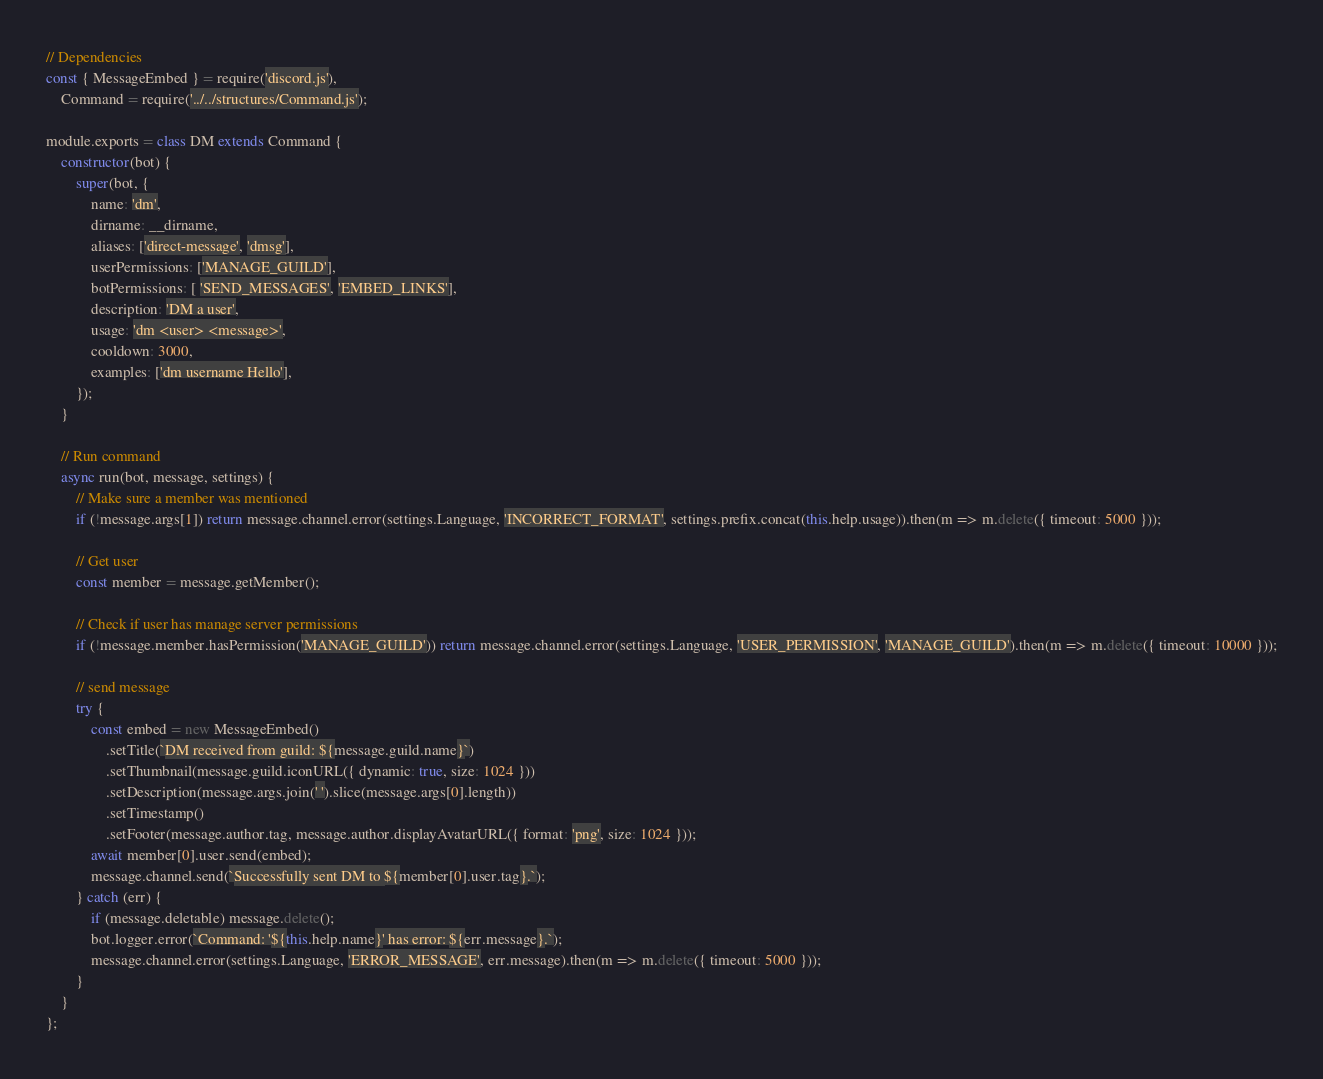Convert code to text. <code><loc_0><loc_0><loc_500><loc_500><_JavaScript_>// Dependencies
const { MessageEmbed } = require('discord.js'),
	Command = require('../../structures/Command.js');

module.exports = class DM extends Command {
	constructor(bot) {
		super(bot, {
			name: 'dm',
			dirname: __dirname,
			aliases: ['direct-message', 'dmsg'],
			userPermissions: ['MANAGE_GUILD'],
			botPermissions: [ 'SEND_MESSAGES', 'EMBED_LINKS'],
			description: 'DM a user',
			usage: 'dm <user> <message>',
			cooldown: 3000,
			examples: ['dm username Hello'],
		});
	}

	// Run command
	async run(bot, message, settings) {
		// Make sure a member was mentioned
		if (!message.args[1]) return message.channel.error(settings.Language, 'INCORRECT_FORMAT', settings.prefix.concat(this.help.usage)).then(m => m.delete({ timeout: 5000 }));

		// Get user
		const member = message.getMember();

		// Check if user has manage server permissions
		if (!message.member.hasPermission('MANAGE_GUILD')) return message.channel.error(settings.Language, 'USER_PERMISSION', 'MANAGE_GUILD').then(m => m.delete({ timeout: 10000 }));

		// send message
		try {
			const embed = new MessageEmbed()
				.setTitle(`DM received from guild: ${message.guild.name}`)
				.setThumbnail(message.guild.iconURL({ dynamic: true, size: 1024 }))
				.setDescription(message.args.join(' ').slice(message.args[0].length))
				.setTimestamp()
				.setFooter(message.author.tag, message.author.displayAvatarURL({ format: 'png', size: 1024 }));
			await member[0].user.send(embed);
			message.channel.send(`Successfully sent DM to ${member[0].user.tag}.`);
		} catch (err) {
			if (message.deletable) message.delete();
			bot.logger.error(`Command: '${this.help.name}' has error: ${err.message}.`);
			message.channel.error(settings.Language, 'ERROR_MESSAGE', err.message).then(m => m.delete({ timeout: 5000 }));
		}
	}
};
</code> 